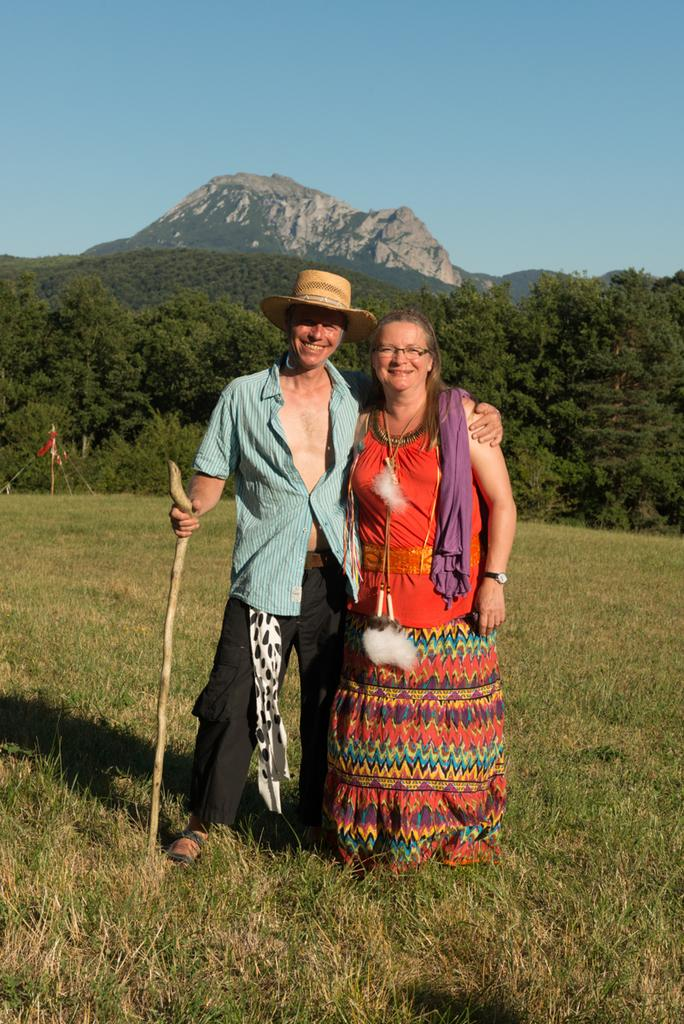How many people are in the image? There is a man and a woman in the image. What are the man and woman doing in the image? The man and woman are standing on the grass and holding sticks. What can be seen in the background of the image? There are trees and hills visible in the background of the image. What type of pan is being used by the man and woman in the image? There is no pan present in the image; the man and woman are holding sticks. 